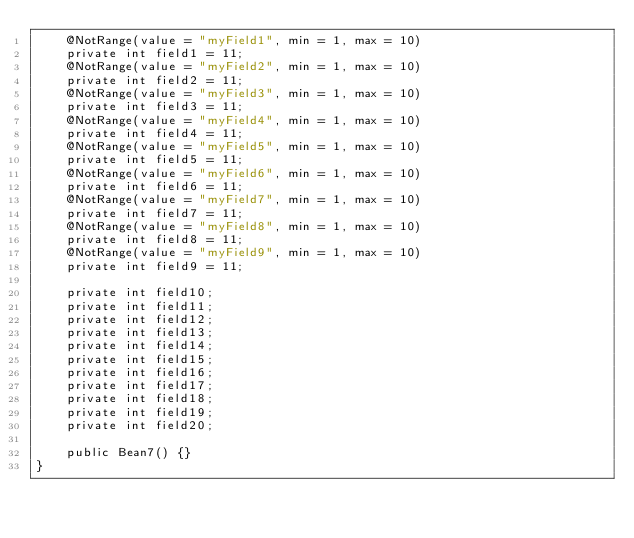<code> <loc_0><loc_0><loc_500><loc_500><_Java_>    @NotRange(value = "myField1", min = 1, max = 10)
    private int field1 = 11;
    @NotRange(value = "myField2", min = 1, max = 10)
    private int field2 = 11;
    @NotRange(value = "myField3", min = 1, max = 10)
    private int field3 = 11;
    @NotRange(value = "myField4", min = 1, max = 10)
    private int field4 = 11;
    @NotRange(value = "myField5", min = 1, max = 10)
    private int field5 = 11;
    @NotRange(value = "myField6", min = 1, max = 10)
    private int field6 = 11;
    @NotRange(value = "myField7", min = 1, max = 10)
    private int field7 = 11;
    @NotRange(value = "myField8", min = 1, max = 10)
    private int field8 = 11;
    @NotRange(value = "myField9", min = 1, max = 10)
    private int field9 = 11;

    private int field10;
    private int field11;
    private int field12;
    private int field13;
    private int field14;
    private int field15;
    private int field16;
    private int field17;
    private int field18;
    private int field19;
    private int field20;

    public Bean7() {}
}
</code> 